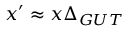Convert formula to latex. <formula><loc_0><loc_0><loc_500><loc_500>x ^ { \prime } \approx x \Delta _ { G U T }</formula> 